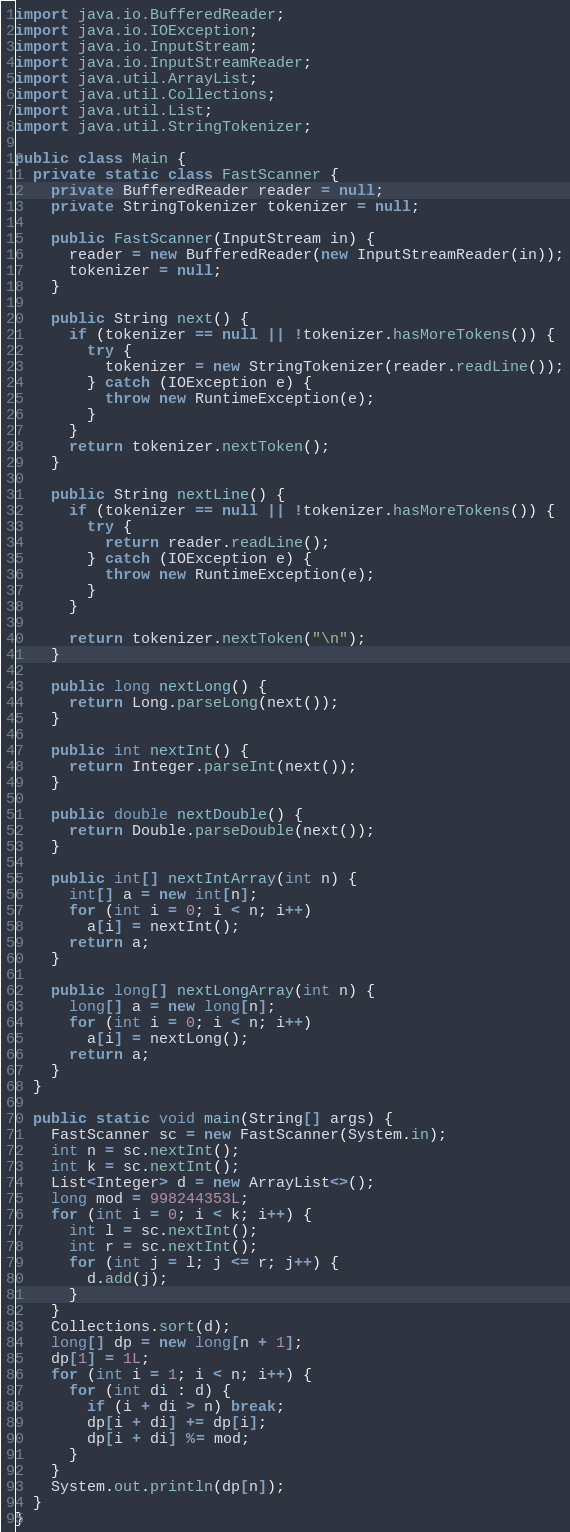<code> <loc_0><loc_0><loc_500><loc_500><_Java_>import java.io.BufferedReader;
import java.io.IOException;
import java.io.InputStream;
import java.io.InputStreamReader;
import java.util.ArrayList;
import java.util.Collections;
import java.util.List;
import java.util.StringTokenizer;

public class Main {
  private static class FastScanner {
    private BufferedReader reader = null;
    private StringTokenizer tokenizer = null;

    public FastScanner(InputStream in) {
      reader = new BufferedReader(new InputStreamReader(in));
      tokenizer = null;
    }

    public String next() {
      if (tokenizer == null || !tokenizer.hasMoreTokens()) {
        try {
          tokenizer = new StringTokenizer(reader.readLine());
        } catch (IOException e) {
          throw new RuntimeException(e);
        }
      }
      return tokenizer.nextToken();
    }

    public String nextLine() {
      if (tokenizer == null || !tokenizer.hasMoreTokens()) {
        try {
          return reader.readLine();
        } catch (IOException e) {
          throw new RuntimeException(e);
        }
      }

      return tokenizer.nextToken("\n");
    }

    public long nextLong() {
      return Long.parseLong(next());
    }

    public int nextInt() {
      return Integer.parseInt(next());
    }

    public double nextDouble() {
      return Double.parseDouble(next());
    }

    public int[] nextIntArray(int n) {
      int[] a = new int[n];
      for (int i = 0; i < n; i++)
        a[i] = nextInt();
      return a;
    }

    public long[] nextLongArray(int n) {
      long[] a = new long[n];
      for (int i = 0; i < n; i++)
        a[i] = nextLong();
      return a;
    }
  }

  public static void main(String[] args) {
    FastScanner sc = new FastScanner(System.in);
    int n = sc.nextInt();
    int k = sc.nextInt();
    List<Integer> d = new ArrayList<>();
    long mod = 998244353L;
    for (int i = 0; i < k; i++) {
      int l = sc.nextInt();
      int r = sc.nextInt();
      for (int j = l; j <= r; j++) {
        d.add(j);
      }
    }
    Collections.sort(d);
    long[] dp = new long[n + 1];
    dp[1] = 1L;
    for (int i = 1; i < n; i++) {
      for (int di : d) {
        if (i + di > n) break;
        dp[i + di] += dp[i];
        dp[i + di] %= mod;
      }
    }
    System.out.println(dp[n]);
  }
}</code> 